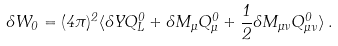<formula> <loc_0><loc_0><loc_500><loc_500>\delta W _ { 0 } = ( 4 \pi ) ^ { 2 } \langle \delta Y Q ^ { 0 } _ { L } + \delta M _ { \mu } Q ^ { 0 } _ { \mu } + \frac { 1 } { 2 } \delta M _ { \mu \nu } Q ^ { 0 } _ { \mu \nu } \rangle \, .</formula> 